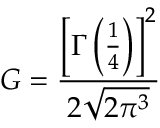<formula> <loc_0><loc_0><loc_500><loc_500>G = { \frac { \left [ \Gamma \left ( { \frac { 1 } { 4 } } \right ) \right ] ^ { 2 } } { 2 { \sqrt { 2 \pi ^ { 3 } } } } }</formula> 